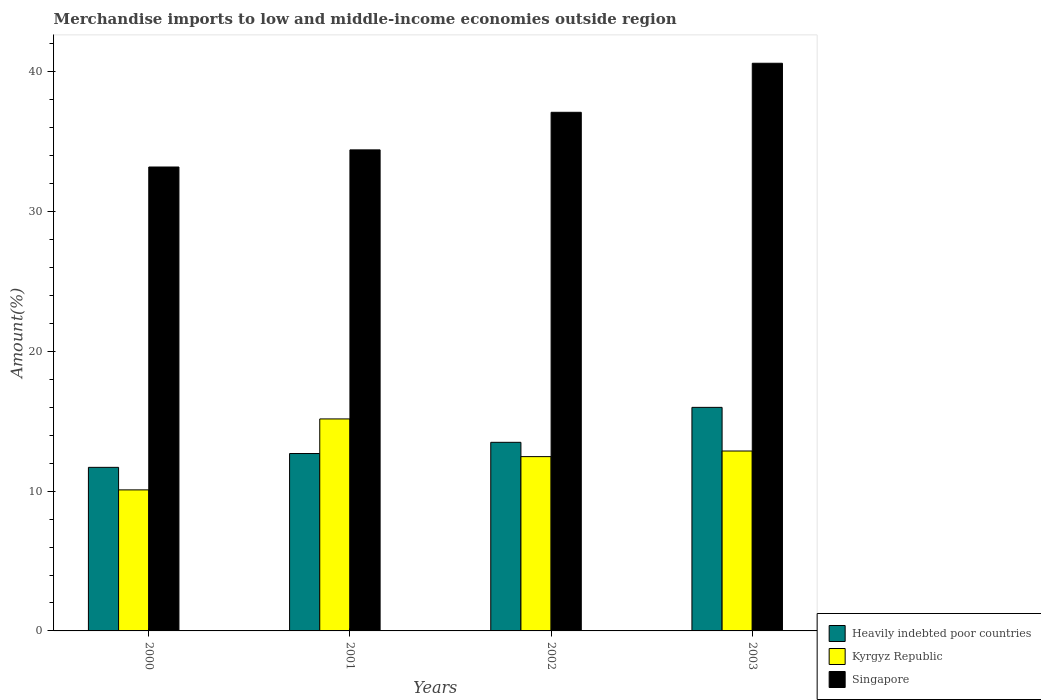How many different coloured bars are there?
Offer a very short reply. 3. Are the number of bars per tick equal to the number of legend labels?
Offer a terse response. Yes. Are the number of bars on each tick of the X-axis equal?
Your answer should be compact. Yes. How many bars are there on the 3rd tick from the left?
Your answer should be very brief. 3. How many bars are there on the 1st tick from the right?
Your answer should be very brief. 3. What is the label of the 4th group of bars from the left?
Offer a terse response. 2003. In how many cases, is the number of bars for a given year not equal to the number of legend labels?
Make the answer very short. 0. What is the percentage of amount earned from merchandise imports in Kyrgyz Republic in 2002?
Provide a succinct answer. 12.47. Across all years, what is the maximum percentage of amount earned from merchandise imports in Heavily indebted poor countries?
Offer a terse response. 15.99. Across all years, what is the minimum percentage of amount earned from merchandise imports in Singapore?
Make the answer very short. 33.19. What is the total percentage of amount earned from merchandise imports in Kyrgyz Republic in the graph?
Offer a very short reply. 50.6. What is the difference between the percentage of amount earned from merchandise imports in Heavily indebted poor countries in 2002 and that in 2003?
Ensure brevity in your answer.  -2.5. What is the difference between the percentage of amount earned from merchandise imports in Singapore in 2003 and the percentage of amount earned from merchandise imports in Heavily indebted poor countries in 2002?
Give a very brief answer. 27.12. What is the average percentage of amount earned from merchandise imports in Singapore per year?
Give a very brief answer. 36.33. In the year 2000, what is the difference between the percentage of amount earned from merchandise imports in Kyrgyz Republic and percentage of amount earned from merchandise imports in Singapore?
Your answer should be very brief. -23.1. What is the ratio of the percentage of amount earned from merchandise imports in Heavily indebted poor countries in 2002 to that in 2003?
Keep it short and to the point. 0.84. Is the percentage of amount earned from merchandise imports in Singapore in 2000 less than that in 2003?
Keep it short and to the point. Yes. Is the difference between the percentage of amount earned from merchandise imports in Kyrgyz Republic in 2000 and 2001 greater than the difference between the percentage of amount earned from merchandise imports in Singapore in 2000 and 2001?
Make the answer very short. No. What is the difference between the highest and the second highest percentage of amount earned from merchandise imports in Heavily indebted poor countries?
Give a very brief answer. 2.5. What is the difference between the highest and the lowest percentage of amount earned from merchandise imports in Singapore?
Offer a very short reply. 7.42. In how many years, is the percentage of amount earned from merchandise imports in Heavily indebted poor countries greater than the average percentage of amount earned from merchandise imports in Heavily indebted poor countries taken over all years?
Your response must be concise. 2. What does the 2nd bar from the left in 2002 represents?
Your answer should be very brief. Kyrgyz Republic. What does the 2nd bar from the right in 2001 represents?
Offer a very short reply. Kyrgyz Republic. How many legend labels are there?
Your response must be concise. 3. What is the title of the graph?
Keep it short and to the point. Merchandise imports to low and middle-income economies outside region. What is the label or title of the X-axis?
Your answer should be very brief. Years. What is the label or title of the Y-axis?
Ensure brevity in your answer.  Amount(%). What is the Amount(%) of Heavily indebted poor countries in 2000?
Provide a short and direct response. 11.7. What is the Amount(%) in Kyrgyz Republic in 2000?
Offer a very short reply. 10.09. What is the Amount(%) of Singapore in 2000?
Keep it short and to the point. 33.19. What is the Amount(%) of Heavily indebted poor countries in 2001?
Keep it short and to the point. 12.69. What is the Amount(%) in Kyrgyz Republic in 2001?
Make the answer very short. 15.17. What is the Amount(%) in Singapore in 2001?
Your response must be concise. 34.41. What is the Amount(%) of Heavily indebted poor countries in 2002?
Offer a very short reply. 13.49. What is the Amount(%) in Kyrgyz Republic in 2002?
Provide a short and direct response. 12.47. What is the Amount(%) in Singapore in 2002?
Offer a very short reply. 37.1. What is the Amount(%) of Heavily indebted poor countries in 2003?
Make the answer very short. 15.99. What is the Amount(%) in Kyrgyz Republic in 2003?
Your answer should be very brief. 12.87. What is the Amount(%) in Singapore in 2003?
Your response must be concise. 40.61. Across all years, what is the maximum Amount(%) in Heavily indebted poor countries?
Offer a very short reply. 15.99. Across all years, what is the maximum Amount(%) of Kyrgyz Republic?
Offer a terse response. 15.17. Across all years, what is the maximum Amount(%) in Singapore?
Provide a short and direct response. 40.61. Across all years, what is the minimum Amount(%) of Heavily indebted poor countries?
Offer a terse response. 11.7. Across all years, what is the minimum Amount(%) of Kyrgyz Republic?
Provide a succinct answer. 10.09. Across all years, what is the minimum Amount(%) of Singapore?
Offer a very short reply. 33.19. What is the total Amount(%) of Heavily indebted poor countries in the graph?
Give a very brief answer. 53.88. What is the total Amount(%) in Kyrgyz Republic in the graph?
Provide a succinct answer. 50.6. What is the total Amount(%) of Singapore in the graph?
Your answer should be compact. 145.32. What is the difference between the Amount(%) of Heavily indebted poor countries in 2000 and that in 2001?
Your answer should be compact. -0.99. What is the difference between the Amount(%) in Kyrgyz Republic in 2000 and that in 2001?
Offer a terse response. -5.08. What is the difference between the Amount(%) of Singapore in 2000 and that in 2001?
Offer a very short reply. -1.23. What is the difference between the Amount(%) of Heavily indebted poor countries in 2000 and that in 2002?
Your answer should be very brief. -1.79. What is the difference between the Amount(%) in Kyrgyz Republic in 2000 and that in 2002?
Make the answer very short. -2.38. What is the difference between the Amount(%) in Singapore in 2000 and that in 2002?
Offer a terse response. -3.91. What is the difference between the Amount(%) in Heavily indebted poor countries in 2000 and that in 2003?
Make the answer very short. -4.29. What is the difference between the Amount(%) in Kyrgyz Republic in 2000 and that in 2003?
Provide a short and direct response. -2.78. What is the difference between the Amount(%) in Singapore in 2000 and that in 2003?
Your answer should be very brief. -7.42. What is the difference between the Amount(%) of Heavily indebted poor countries in 2001 and that in 2002?
Your answer should be very brief. -0.8. What is the difference between the Amount(%) in Kyrgyz Republic in 2001 and that in 2002?
Make the answer very short. 2.7. What is the difference between the Amount(%) in Singapore in 2001 and that in 2002?
Offer a very short reply. -2.69. What is the difference between the Amount(%) of Heavily indebted poor countries in 2001 and that in 2003?
Offer a terse response. -3.3. What is the difference between the Amount(%) of Kyrgyz Republic in 2001 and that in 2003?
Keep it short and to the point. 2.29. What is the difference between the Amount(%) of Singapore in 2001 and that in 2003?
Give a very brief answer. -6.2. What is the difference between the Amount(%) in Heavily indebted poor countries in 2002 and that in 2003?
Your answer should be compact. -2.5. What is the difference between the Amount(%) of Kyrgyz Republic in 2002 and that in 2003?
Make the answer very short. -0.4. What is the difference between the Amount(%) of Singapore in 2002 and that in 2003?
Offer a very short reply. -3.51. What is the difference between the Amount(%) of Heavily indebted poor countries in 2000 and the Amount(%) of Kyrgyz Republic in 2001?
Offer a terse response. -3.46. What is the difference between the Amount(%) in Heavily indebted poor countries in 2000 and the Amount(%) in Singapore in 2001?
Your answer should be very brief. -22.71. What is the difference between the Amount(%) in Kyrgyz Republic in 2000 and the Amount(%) in Singapore in 2001?
Ensure brevity in your answer.  -24.32. What is the difference between the Amount(%) of Heavily indebted poor countries in 2000 and the Amount(%) of Kyrgyz Republic in 2002?
Give a very brief answer. -0.77. What is the difference between the Amount(%) in Heavily indebted poor countries in 2000 and the Amount(%) in Singapore in 2002?
Your answer should be very brief. -25.4. What is the difference between the Amount(%) of Kyrgyz Republic in 2000 and the Amount(%) of Singapore in 2002?
Offer a very short reply. -27.01. What is the difference between the Amount(%) in Heavily indebted poor countries in 2000 and the Amount(%) in Kyrgyz Republic in 2003?
Give a very brief answer. -1.17. What is the difference between the Amount(%) in Heavily indebted poor countries in 2000 and the Amount(%) in Singapore in 2003?
Offer a terse response. -28.91. What is the difference between the Amount(%) in Kyrgyz Republic in 2000 and the Amount(%) in Singapore in 2003?
Provide a short and direct response. -30.52. What is the difference between the Amount(%) of Heavily indebted poor countries in 2001 and the Amount(%) of Kyrgyz Republic in 2002?
Keep it short and to the point. 0.22. What is the difference between the Amount(%) of Heavily indebted poor countries in 2001 and the Amount(%) of Singapore in 2002?
Provide a short and direct response. -24.41. What is the difference between the Amount(%) of Kyrgyz Republic in 2001 and the Amount(%) of Singapore in 2002?
Offer a terse response. -21.94. What is the difference between the Amount(%) in Heavily indebted poor countries in 2001 and the Amount(%) in Kyrgyz Republic in 2003?
Give a very brief answer. -0.18. What is the difference between the Amount(%) of Heavily indebted poor countries in 2001 and the Amount(%) of Singapore in 2003?
Give a very brief answer. -27.92. What is the difference between the Amount(%) in Kyrgyz Republic in 2001 and the Amount(%) in Singapore in 2003?
Your answer should be very brief. -25.45. What is the difference between the Amount(%) in Heavily indebted poor countries in 2002 and the Amount(%) in Kyrgyz Republic in 2003?
Ensure brevity in your answer.  0.62. What is the difference between the Amount(%) in Heavily indebted poor countries in 2002 and the Amount(%) in Singapore in 2003?
Ensure brevity in your answer.  -27.12. What is the difference between the Amount(%) of Kyrgyz Republic in 2002 and the Amount(%) of Singapore in 2003?
Keep it short and to the point. -28.14. What is the average Amount(%) of Heavily indebted poor countries per year?
Your response must be concise. 13.47. What is the average Amount(%) of Kyrgyz Republic per year?
Keep it short and to the point. 12.65. What is the average Amount(%) of Singapore per year?
Keep it short and to the point. 36.33. In the year 2000, what is the difference between the Amount(%) of Heavily indebted poor countries and Amount(%) of Kyrgyz Republic?
Ensure brevity in your answer.  1.61. In the year 2000, what is the difference between the Amount(%) in Heavily indebted poor countries and Amount(%) in Singapore?
Make the answer very short. -21.49. In the year 2000, what is the difference between the Amount(%) of Kyrgyz Republic and Amount(%) of Singapore?
Provide a short and direct response. -23.1. In the year 2001, what is the difference between the Amount(%) of Heavily indebted poor countries and Amount(%) of Kyrgyz Republic?
Make the answer very short. -2.48. In the year 2001, what is the difference between the Amount(%) of Heavily indebted poor countries and Amount(%) of Singapore?
Ensure brevity in your answer.  -21.72. In the year 2001, what is the difference between the Amount(%) in Kyrgyz Republic and Amount(%) in Singapore?
Your response must be concise. -19.25. In the year 2002, what is the difference between the Amount(%) of Heavily indebted poor countries and Amount(%) of Kyrgyz Republic?
Make the answer very short. 1.02. In the year 2002, what is the difference between the Amount(%) of Heavily indebted poor countries and Amount(%) of Singapore?
Offer a terse response. -23.61. In the year 2002, what is the difference between the Amount(%) in Kyrgyz Republic and Amount(%) in Singapore?
Give a very brief answer. -24.63. In the year 2003, what is the difference between the Amount(%) of Heavily indebted poor countries and Amount(%) of Kyrgyz Republic?
Provide a succinct answer. 3.12. In the year 2003, what is the difference between the Amount(%) in Heavily indebted poor countries and Amount(%) in Singapore?
Keep it short and to the point. -24.62. In the year 2003, what is the difference between the Amount(%) in Kyrgyz Republic and Amount(%) in Singapore?
Your answer should be compact. -27.74. What is the ratio of the Amount(%) of Heavily indebted poor countries in 2000 to that in 2001?
Make the answer very short. 0.92. What is the ratio of the Amount(%) of Kyrgyz Republic in 2000 to that in 2001?
Provide a short and direct response. 0.67. What is the ratio of the Amount(%) of Singapore in 2000 to that in 2001?
Your answer should be very brief. 0.96. What is the ratio of the Amount(%) in Heavily indebted poor countries in 2000 to that in 2002?
Offer a very short reply. 0.87. What is the ratio of the Amount(%) in Kyrgyz Republic in 2000 to that in 2002?
Keep it short and to the point. 0.81. What is the ratio of the Amount(%) in Singapore in 2000 to that in 2002?
Provide a short and direct response. 0.89. What is the ratio of the Amount(%) in Heavily indebted poor countries in 2000 to that in 2003?
Provide a succinct answer. 0.73. What is the ratio of the Amount(%) in Kyrgyz Republic in 2000 to that in 2003?
Keep it short and to the point. 0.78. What is the ratio of the Amount(%) of Singapore in 2000 to that in 2003?
Give a very brief answer. 0.82. What is the ratio of the Amount(%) in Heavily indebted poor countries in 2001 to that in 2002?
Offer a very short reply. 0.94. What is the ratio of the Amount(%) in Kyrgyz Republic in 2001 to that in 2002?
Give a very brief answer. 1.22. What is the ratio of the Amount(%) in Singapore in 2001 to that in 2002?
Offer a very short reply. 0.93. What is the ratio of the Amount(%) in Heavily indebted poor countries in 2001 to that in 2003?
Your answer should be compact. 0.79. What is the ratio of the Amount(%) in Kyrgyz Republic in 2001 to that in 2003?
Ensure brevity in your answer.  1.18. What is the ratio of the Amount(%) in Singapore in 2001 to that in 2003?
Your response must be concise. 0.85. What is the ratio of the Amount(%) of Heavily indebted poor countries in 2002 to that in 2003?
Give a very brief answer. 0.84. What is the ratio of the Amount(%) of Kyrgyz Republic in 2002 to that in 2003?
Give a very brief answer. 0.97. What is the ratio of the Amount(%) of Singapore in 2002 to that in 2003?
Make the answer very short. 0.91. What is the difference between the highest and the second highest Amount(%) in Heavily indebted poor countries?
Offer a terse response. 2.5. What is the difference between the highest and the second highest Amount(%) of Kyrgyz Republic?
Keep it short and to the point. 2.29. What is the difference between the highest and the second highest Amount(%) of Singapore?
Offer a very short reply. 3.51. What is the difference between the highest and the lowest Amount(%) in Heavily indebted poor countries?
Provide a short and direct response. 4.29. What is the difference between the highest and the lowest Amount(%) of Kyrgyz Republic?
Give a very brief answer. 5.08. What is the difference between the highest and the lowest Amount(%) of Singapore?
Give a very brief answer. 7.42. 